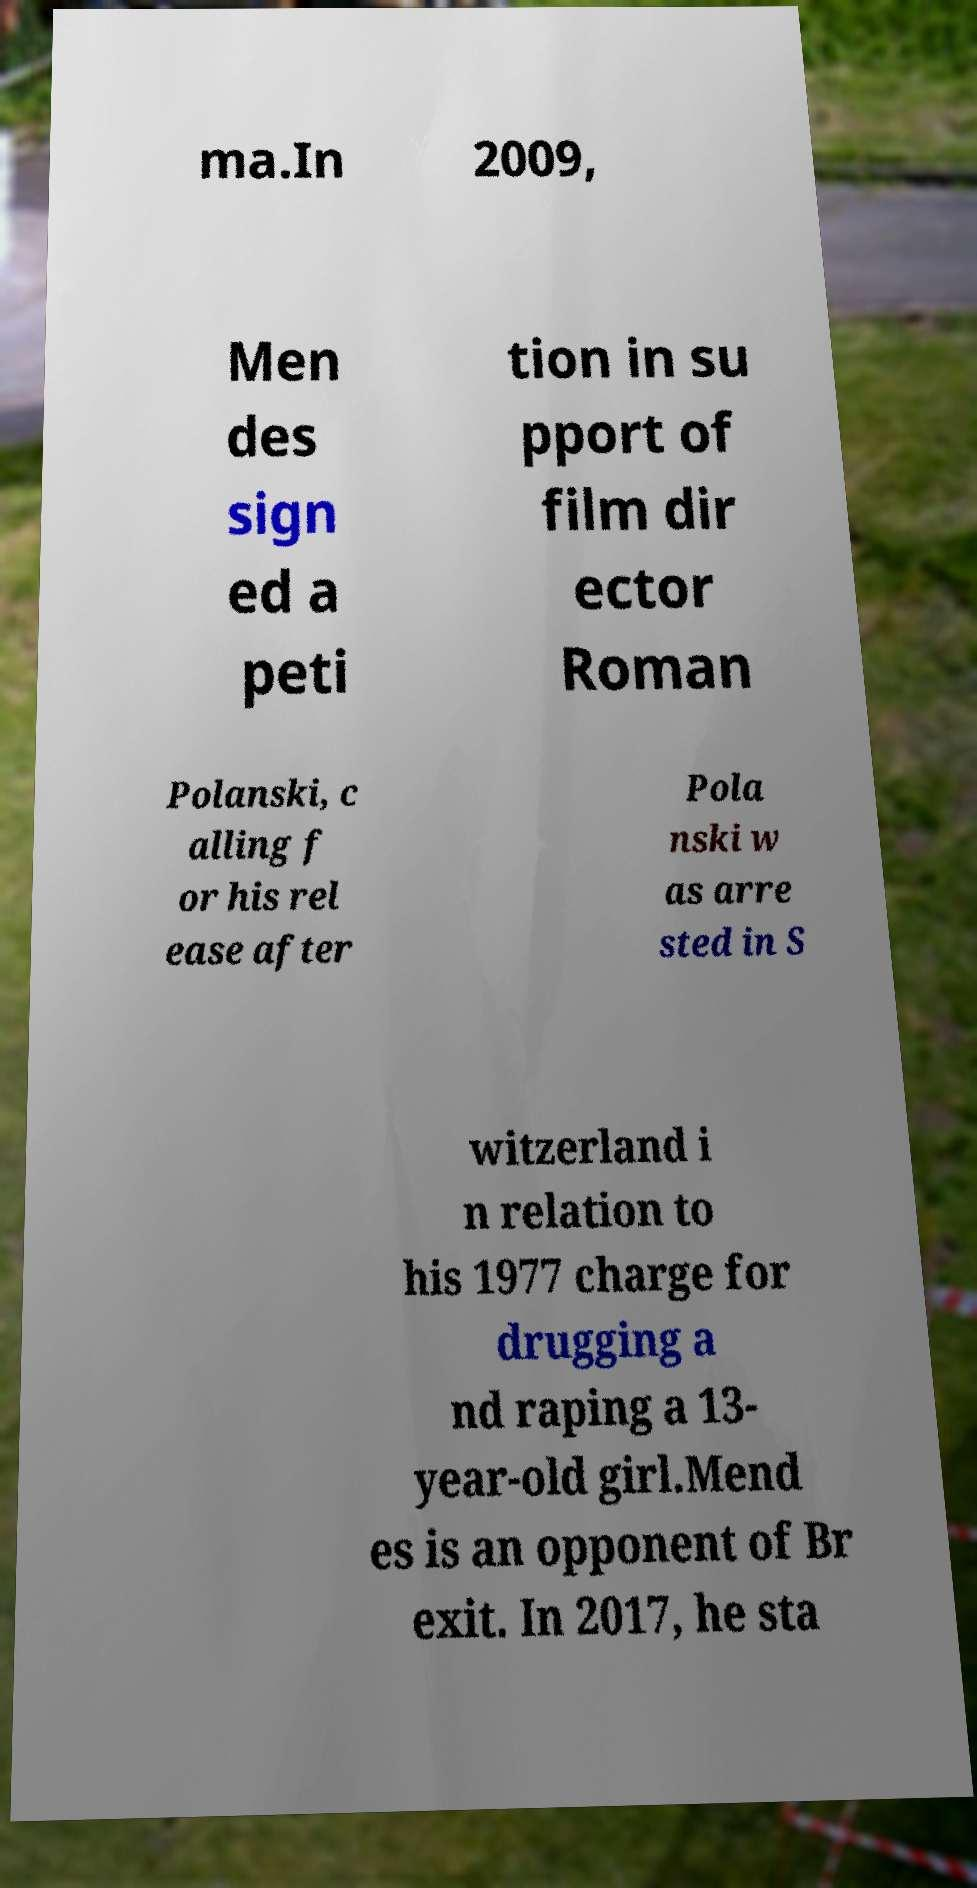Can you read and provide the text displayed in the image?This photo seems to have some interesting text. Can you extract and type it out for me? ma.In 2009, Men des sign ed a peti tion in su pport of film dir ector Roman Polanski, c alling f or his rel ease after Pola nski w as arre sted in S witzerland i n relation to his 1977 charge for drugging a nd raping a 13- year-old girl.Mend es is an opponent of Br exit. In 2017, he sta 